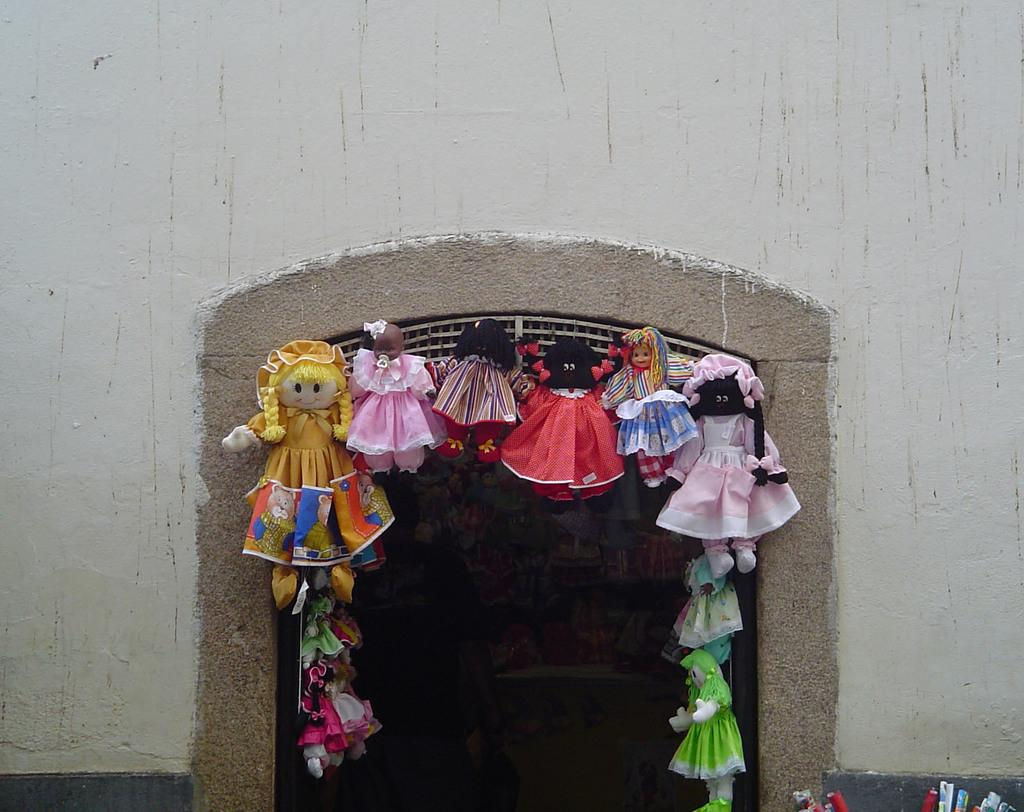What is the main subject of the image? There is a group of dolls hanging in the center of the image. What can be seen behind the dolls? There is a wall visible in the image. What other objects are present in the image? There are other objects present in the image, but their specific details are not mentioned in the provided facts. What can be seen in the background of the image? There are other objects visible in the background of the image, but their specific details are not mentioned in the provided facts. What type of jam is being spread on the dime in the image? There is no jam or dime present in the image; it features a group of dolls hanging and a wall visible in the background. 